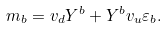<formula> <loc_0><loc_0><loc_500><loc_500>m _ { b } = v _ { d } Y ^ { b } + Y ^ { b } v _ { u } \varepsilon _ { b } .</formula> 